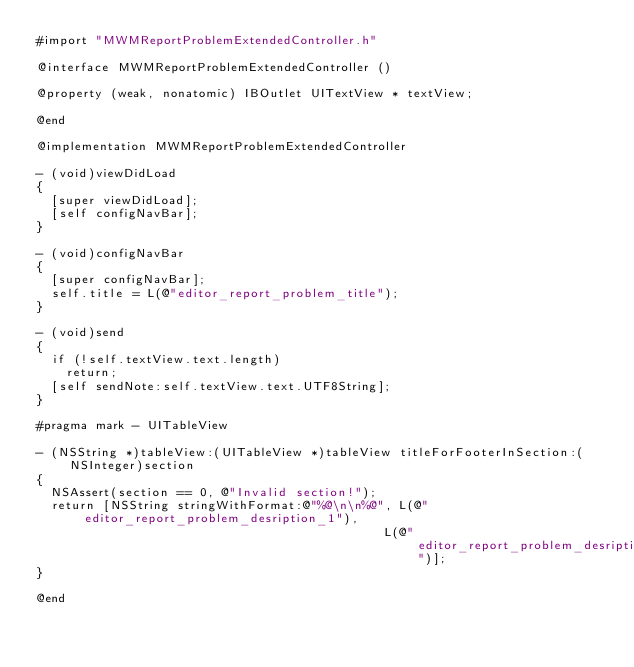Convert code to text. <code><loc_0><loc_0><loc_500><loc_500><_ObjectiveC_>#import "MWMReportProblemExtendedController.h"

@interface MWMReportProblemExtendedController ()

@property (weak, nonatomic) IBOutlet UITextView * textView;

@end

@implementation MWMReportProblemExtendedController

- (void)viewDidLoad
{
  [super viewDidLoad];
  [self configNavBar];
}

- (void)configNavBar
{
  [super configNavBar];
  self.title = L(@"editor_report_problem_title");
}

- (void)send
{
  if (!self.textView.text.length)
    return;
  [self sendNote:self.textView.text.UTF8String];
}

#pragma mark - UITableView

- (NSString *)tableView:(UITableView *)tableView titleForFooterInSection:(NSInteger)section
{
  NSAssert(section == 0, @"Invalid section!");
  return [NSString stringWithFormat:@"%@\n\n%@", L(@"editor_report_problem_desription_1"),
                                               L(@"editor_report_problem_desription_2")];
}

@end
</code> 